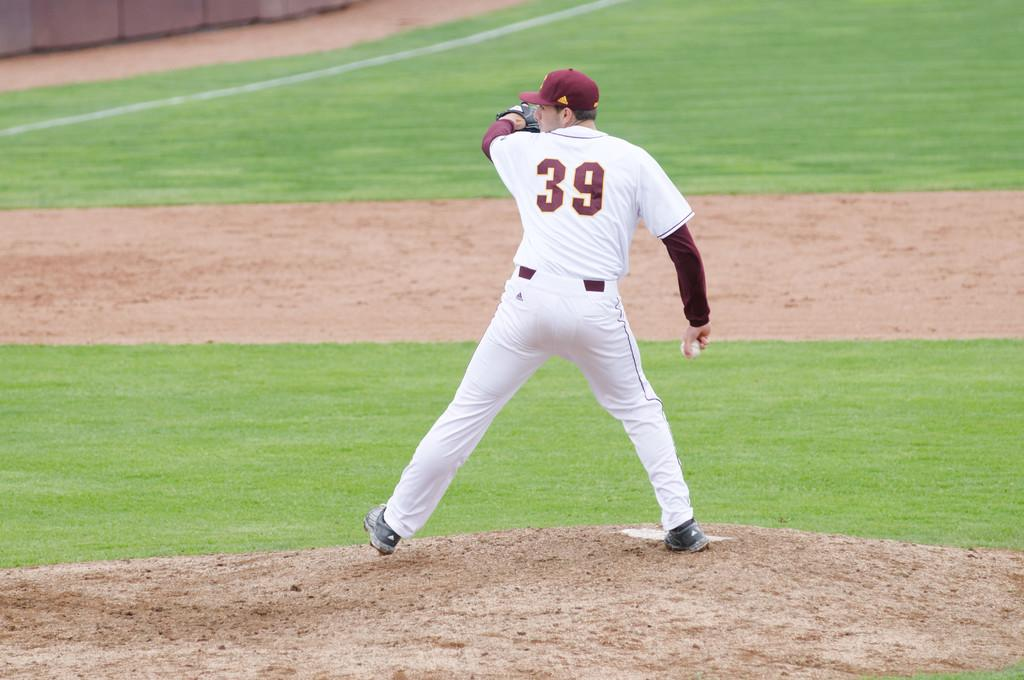<image>
Create a compact narrative representing the image presented. player in white and red number 39 getting ready to pitch the baseball 